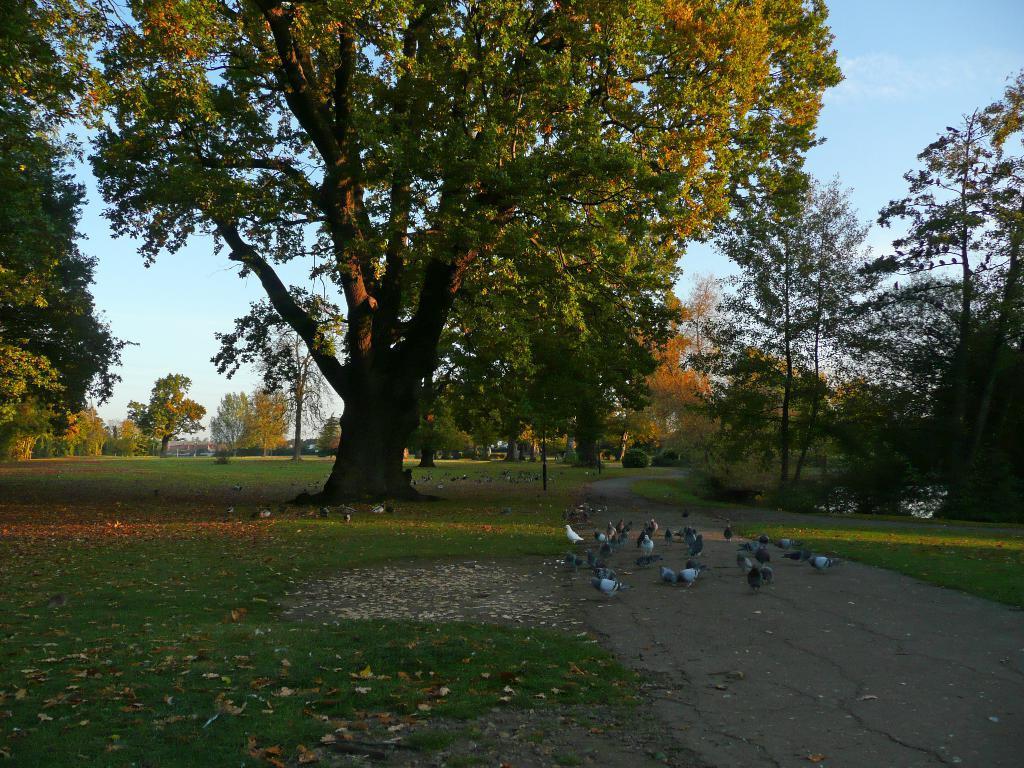Please provide a concise description of this image. In this image, we can see green grass on the ground, there is green grass on the ground, there are some trees, at the top there is a blue color sky. 